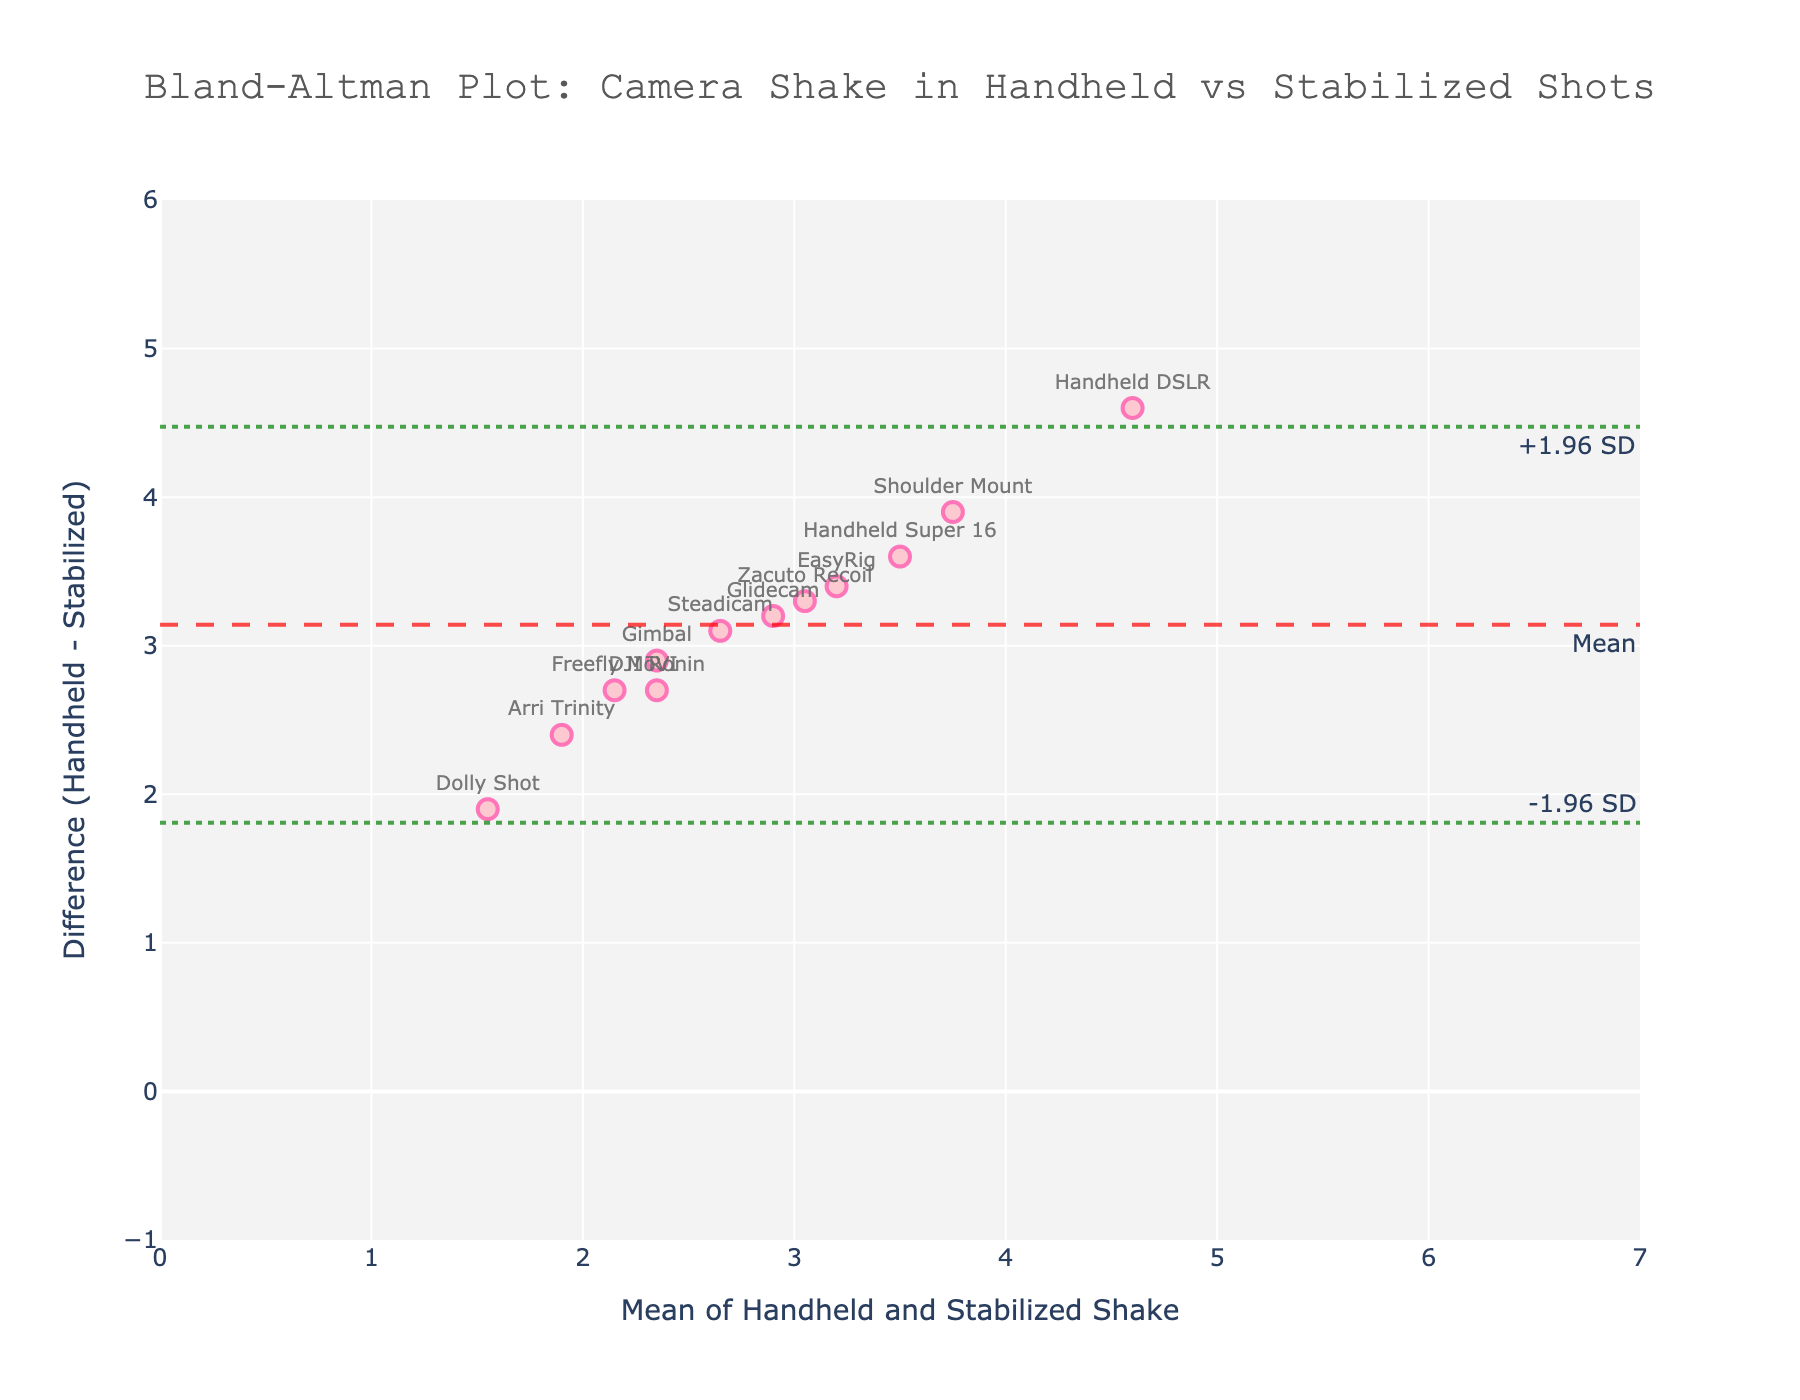What's the title of the plot? The title is displayed at the top of the plot. It states "Bland-Altman Plot: Camera Shake in Handheld vs Stabilized Shots."
Answer: Bland-Altman Plot: Camera Shake in Handheld vs Stabilized Shots How many data points are present in the plot? Each method represents a data point, and they are indicated by markers on the scatter plot. The number of methods listed correlates to the data points present.
Answer: 12 What is the mean line in the plot? The mean line is represented by a dashed line, annotated with "Mean," and indicates the average difference between handheld and stabilized shots.
Answer: The dashed line annotated with "Mean." What is the upper limit of agreement in the plot? The upper limit of agreement is represented by a dotted line annotated with "+1.96 SD." It provides a boundary within which most differences between measurements are expected to lie.
Answer: The dotted line annotated with "+1.96 SD." What is the lower limit of agreement in the plot? The lower limit of agreement is depicted by a dotted line annotated with "-1.96 SD." It marks the lower boundary within which most differences should fall.
Answer: The dotted line annotated with "-1.96 SD." Which method shows the highest difference in the shake measurements? Identify the data point that has the highest position on the y-axis (difference axis). Handheld DSLR appears to be the highest.
Answer: Handheld DSLR What is the mean camera shake for the 'Gimbal' method? The mean is calculated as the average of handheld and stabilized shake. For 'Gimbal': (3.8 + 0.9) / 2 = 2.35.
Answer: 2.35 Which method has the minimum difference between handheld and stabilized shake? Look for the data point with the lowest y-axis value for the difference. 'Dolly Shot' seems to have the smallest difference.
Answer: Dolly Shot How does the 'Handheld Super 16' method compare to 'Steadicam' in terms of shake difference? 'Handheld Super 16' has a higher y-value in comparison to 'Steadicam,' indicating it has a greater difference in shake.
Answer: 'Handheld Super 16' has a higher shake difference What are the upper and lower limits of agreement, numerically? The upper limit is the mean difference plus 1.96 times the standard deviation, and the lower limit is the mean difference minus 1.96 times the standard deviation, as indicated by the plot's annotation.
Answer: Mean + 1.96 SD and Mean - 1.96 SD 